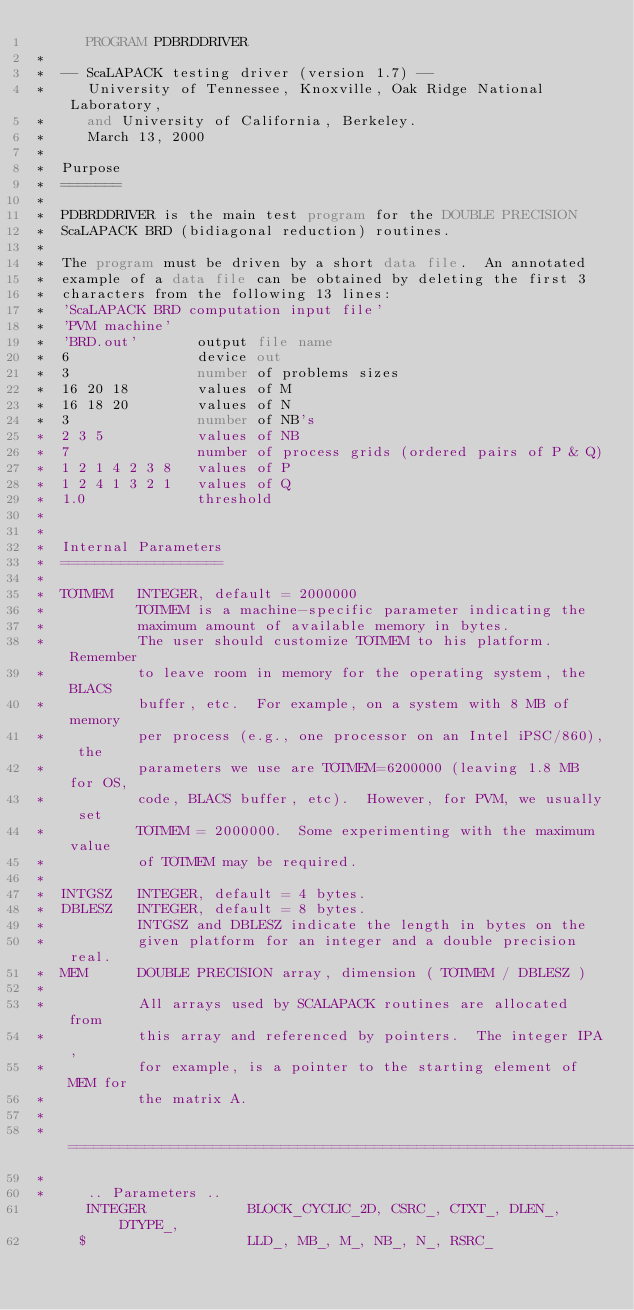Convert code to text. <code><loc_0><loc_0><loc_500><loc_500><_FORTRAN_>      PROGRAM PDBRDDRIVER
*
*  -- ScaLAPACK testing driver (version 1.7) --
*     University of Tennessee, Knoxville, Oak Ridge National Laboratory,
*     and University of California, Berkeley.
*     March 13, 2000
*
*  Purpose
*  =======
*
*  PDBRDDRIVER is the main test program for the DOUBLE PRECISION
*  ScaLAPACK BRD (bidiagonal reduction) routines.
*
*  The program must be driven by a short data file.  An annotated
*  example of a data file can be obtained by deleting the first 3
*  characters from the following 13 lines:
*  'ScaLAPACK BRD computation input file'
*  'PVM machine'
*  'BRD.out'       output file name
*  6               device out
*  3               number of problems sizes
*  16 20 18        values of M
*  16 18 20        values of N
*  3               number of NB's
*  2 3 5           values of NB
*  7               number of process grids (ordered pairs of P & Q)
*  1 2 1 4 2 3 8   values of P
*  1 2 4 1 3 2 1   values of Q
*  1.0             threshold
*
*
*  Internal Parameters
*  ===================
*
*  TOTMEM   INTEGER, default = 2000000
*           TOTMEM is a machine-specific parameter indicating the
*           maximum amount of available memory in bytes.
*           The user should customize TOTMEM to his platform.  Remember
*           to leave room in memory for the operating system, the BLACS
*           buffer, etc.  For example, on a system with 8 MB of memory
*           per process (e.g., one processor on an Intel iPSC/860), the
*           parameters we use are TOTMEM=6200000 (leaving 1.8 MB for OS,
*           code, BLACS buffer, etc).  However, for PVM, we usually set
*           TOTMEM = 2000000.  Some experimenting with the maximum value
*           of TOTMEM may be required.
*
*  INTGSZ   INTEGER, default = 4 bytes.
*  DBLESZ   INTEGER, default = 8 bytes.
*           INTGSZ and DBLESZ indicate the length in bytes on the
*           given platform for an integer and a double precision real.
*  MEM      DOUBLE PRECISION array, dimension ( TOTMEM / DBLESZ )
*
*           All arrays used by SCALAPACK routines are allocated from
*           this array and referenced by pointers.  The integer IPA,
*           for example, is a pointer to the starting element of MEM for
*           the matrix A.
*
*  =====================================================================
*
*     .. Parameters ..
      INTEGER            BLOCK_CYCLIC_2D, CSRC_, CTXT_, DLEN_, DTYPE_,
     $                   LLD_, MB_, M_, NB_, N_, RSRC_</code> 